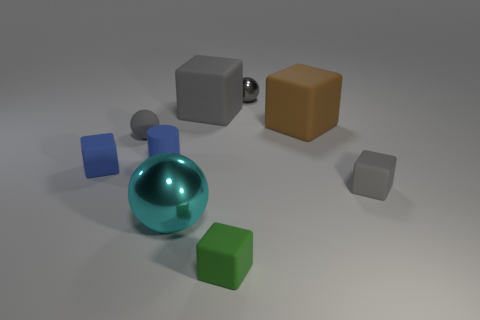What is the shape of the big rubber object that is the same color as the small metal object?
Offer a terse response. Cube. Is the number of tiny brown cubes greater than the number of blue rubber blocks?
Offer a very short reply. No. There is a rubber cube that is on the left side of the tiny gray rubber thing behind the small rubber block left of the green matte block; what color is it?
Ensure brevity in your answer.  Blue. Is the shape of the tiny rubber object in front of the big metal thing the same as  the gray metal object?
Provide a succinct answer. No. What color is the metal sphere that is the same size as the green cube?
Offer a very short reply. Gray. What number of tiny blue rubber objects are there?
Provide a succinct answer. 2. Do the tiny gray thing that is in front of the matte sphere and the large gray block have the same material?
Keep it short and to the point. Yes. There is a small gray thing that is in front of the small metal thing and right of the green matte block; what is it made of?
Your answer should be compact. Rubber. There is another ball that is the same color as the rubber ball; what size is it?
Provide a short and direct response. Small. The tiny block that is in front of the small gray rubber thing that is on the right side of the tiny green thing is made of what material?
Give a very brief answer. Rubber. 